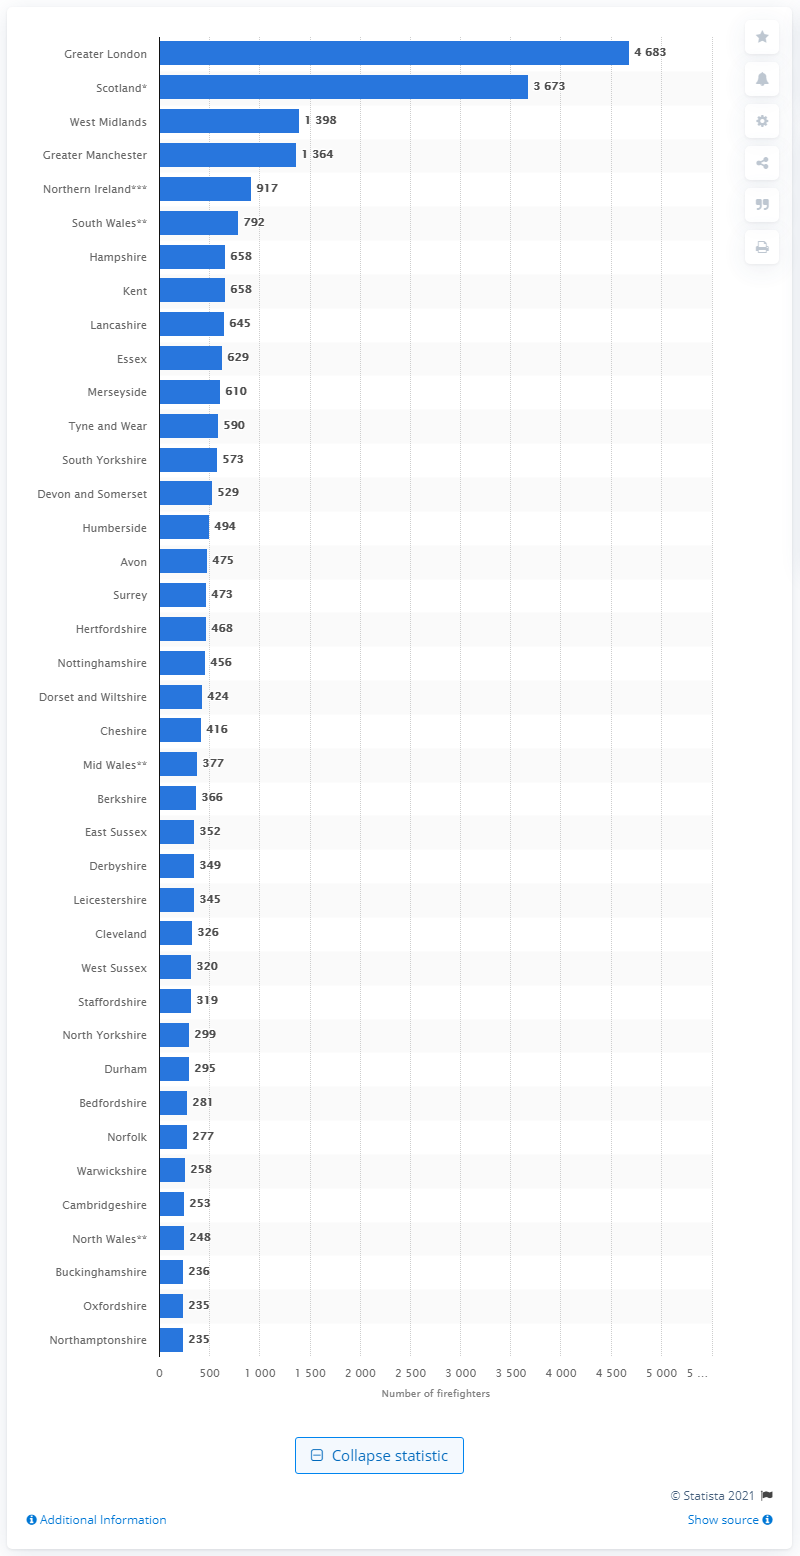Point out several critical features in this image. In 2019, a total of 4,683 firefighters were employed by the London Fire Brigade. There are 1,398 firefighters serving in the West Midlands Fire Brigade. 